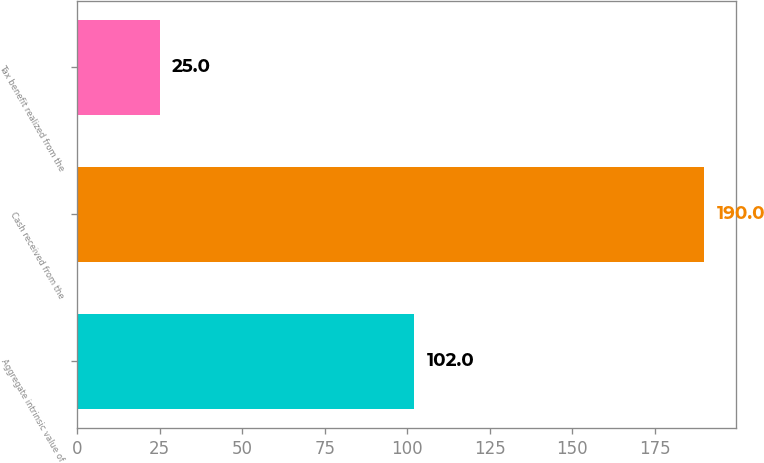<chart> <loc_0><loc_0><loc_500><loc_500><bar_chart><fcel>Aggregate intrinsic value of<fcel>Cash received from the<fcel>Tax benefit realized from the<nl><fcel>102<fcel>190<fcel>25<nl></chart> 